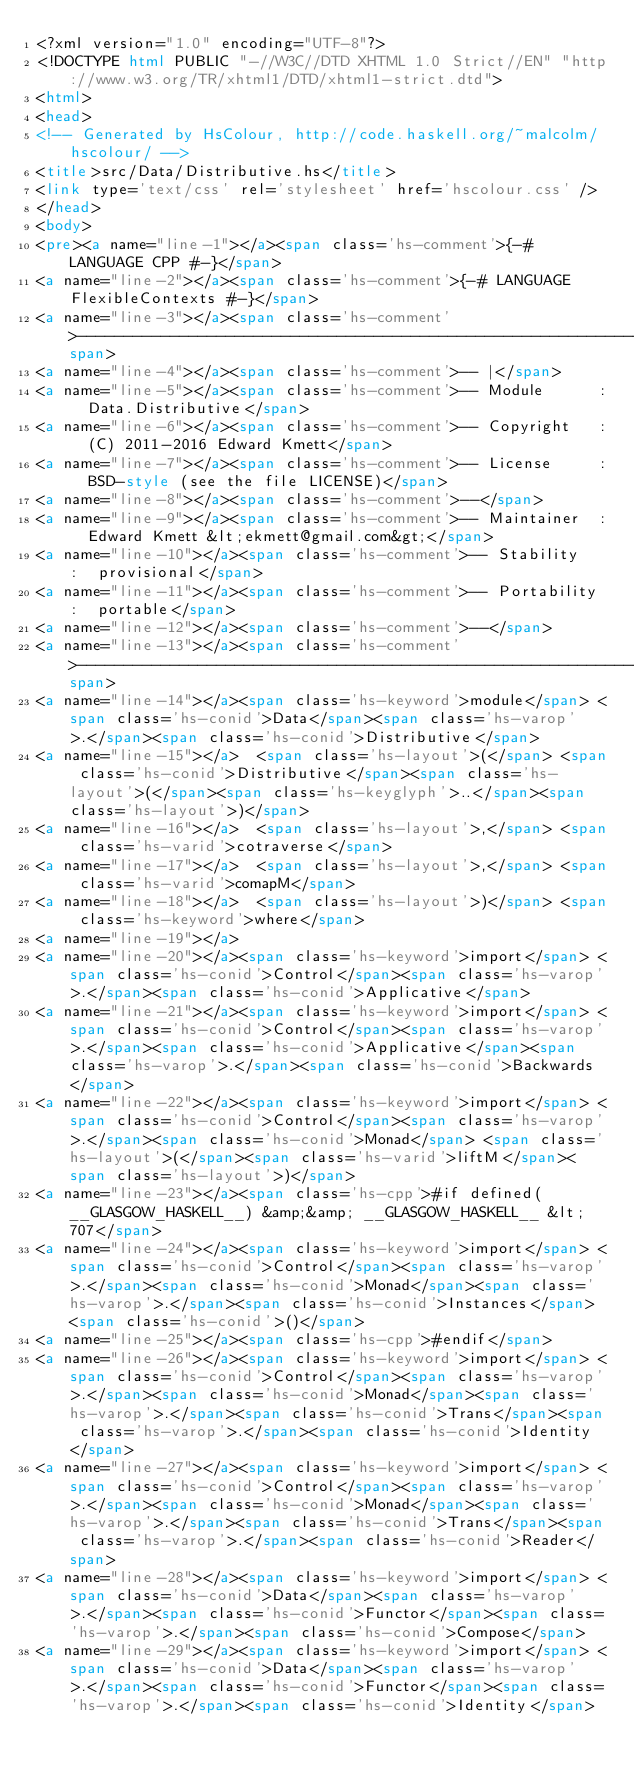<code> <loc_0><loc_0><loc_500><loc_500><_HTML_><?xml version="1.0" encoding="UTF-8"?>
<!DOCTYPE html PUBLIC "-//W3C//DTD XHTML 1.0 Strict//EN" "http://www.w3.org/TR/xhtml1/DTD/xhtml1-strict.dtd">
<html>
<head>
<!-- Generated by HsColour, http://code.haskell.org/~malcolm/hscolour/ -->
<title>src/Data/Distributive.hs</title>
<link type='text/css' rel='stylesheet' href='hscolour.css' />
</head>
<body>
<pre><a name="line-1"></a><span class='hs-comment'>{-# LANGUAGE CPP #-}</span>
<a name="line-2"></a><span class='hs-comment'>{-# LANGUAGE FlexibleContexts #-}</span>
<a name="line-3"></a><span class='hs-comment'>-----------------------------------------------------------------------------</span>
<a name="line-4"></a><span class='hs-comment'>-- |</span>
<a name="line-5"></a><span class='hs-comment'>-- Module      :  Data.Distributive</span>
<a name="line-6"></a><span class='hs-comment'>-- Copyright   :  (C) 2011-2016 Edward Kmett</span>
<a name="line-7"></a><span class='hs-comment'>-- License     :  BSD-style (see the file LICENSE)</span>
<a name="line-8"></a><span class='hs-comment'>--</span>
<a name="line-9"></a><span class='hs-comment'>-- Maintainer  :  Edward Kmett &lt;ekmett@gmail.com&gt;</span>
<a name="line-10"></a><span class='hs-comment'>-- Stability   :  provisional</span>
<a name="line-11"></a><span class='hs-comment'>-- Portability :  portable</span>
<a name="line-12"></a><span class='hs-comment'>--</span>
<a name="line-13"></a><span class='hs-comment'>----------------------------------------------------------------------------</span>
<a name="line-14"></a><span class='hs-keyword'>module</span> <span class='hs-conid'>Data</span><span class='hs-varop'>.</span><span class='hs-conid'>Distributive</span>
<a name="line-15"></a>  <span class='hs-layout'>(</span> <span class='hs-conid'>Distributive</span><span class='hs-layout'>(</span><span class='hs-keyglyph'>..</span><span class='hs-layout'>)</span>
<a name="line-16"></a>  <span class='hs-layout'>,</span> <span class='hs-varid'>cotraverse</span>
<a name="line-17"></a>  <span class='hs-layout'>,</span> <span class='hs-varid'>comapM</span>
<a name="line-18"></a>  <span class='hs-layout'>)</span> <span class='hs-keyword'>where</span>
<a name="line-19"></a>
<a name="line-20"></a><span class='hs-keyword'>import</span> <span class='hs-conid'>Control</span><span class='hs-varop'>.</span><span class='hs-conid'>Applicative</span>
<a name="line-21"></a><span class='hs-keyword'>import</span> <span class='hs-conid'>Control</span><span class='hs-varop'>.</span><span class='hs-conid'>Applicative</span><span class='hs-varop'>.</span><span class='hs-conid'>Backwards</span>
<a name="line-22"></a><span class='hs-keyword'>import</span> <span class='hs-conid'>Control</span><span class='hs-varop'>.</span><span class='hs-conid'>Monad</span> <span class='hs-layout'>(</span><span class='hs-varid'>liftM</span><span class='hs-layout'>)</span>
<a name="line-23"></a><span class='hs-cpp'>#if defined(__GLASGOW_HASKELL__) &amp;&amp; __GLASGOW_HASKELL__ &lt; 707</span>
<a name="line-24"></a><span class='hs-keyword'>import</span> <span class='hs-conid'>Control</span><span class='hs-varop'>.</span><span class='hs-conid'>Monad</span><span class='hs-varop'>.</span><span class='hs-conid'>Instances</span> <span class='hs-conid'>()</span>
<a name="line-25"></a><span class='hs-cpp'>#endif</span>
<a name="line-26"></a><span class='hs-keyword'>import</span> <span class='hs-conid'>Control</span><span class='hs-varop'>.</span><span class='hs-conid'>Monad</span><span class='hs-varop'>.</span><span class='hs-conid'>Trans</span><span class='hs-varop'>.</span><span class='hs-conid'>Identity</span>
<a name="line-27"></a><span class='hs-keyword'>import</span> <span class='hs-conid'>Control</span><span class='hs-varop'>.</span><span class='hs-conid'>Monad</span><span class='hs-varop'>.</span><span class='hs-conid'>Trans</span><span class='hs-varop'>.</span><span class='hs-conid'>Reader</span>
<a name="line-28"></a><span class='hs-keyword'>import</span> <span class='hs-conid'>Data</span><span class='hs-varop'>.</span><span class='hs-conid'>Functor</span><span class='hs-varop'>.</span><span class='hs-conid'>Compose</span>
<a name="line-29"></a><span class='hs-keyword'>import</span> <span class='hs-conid'>Data</span><span class='hs-varop'>.</span><span class='hs-conid'>Functor</span><span class='hs-varop'>.</span><span class='hs-conid'>Identity</span></code> 